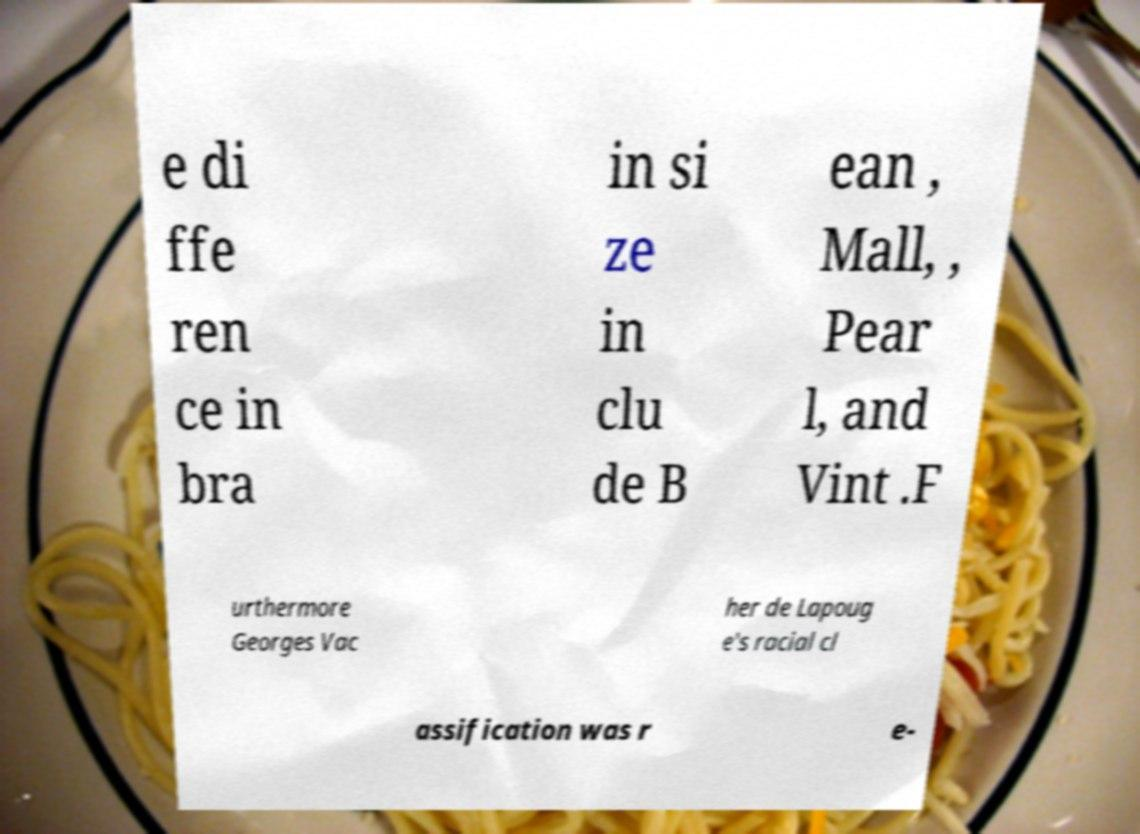Can you read and provide the text displayed in the image?This photo seems to have some interesting text. Can you extract and type it out for me? e di ffe ren ce in bra in si ze in clu de B ean , Mall, , Pear l, and Vint .F urthermore Georges Vac her de Lapoug e's racial cl assification was r e- 